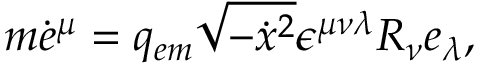Convert formula to latex. <formula><loc_0><loc_0><loc_500><loc_500>m \dot { e } ^ { \mu } = q _ { e m } \sqrt { - \dot { x ^ { 2 } } \epsilon ^ { \mu \nu \lambda } R _ { \nu } e _ { \lambda } ,</formula> 